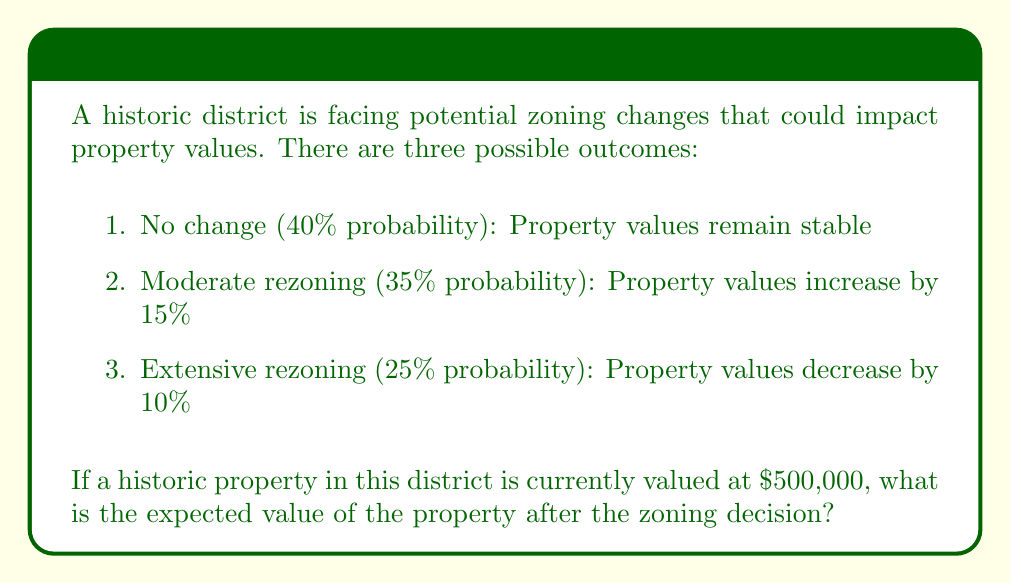Help me with this question. To calculate the expected value, we need to multiply each possible outcome by its probability and sum the results. Let's break it down step-by-step:

1. No change (40% probability):
   $500,000 \times 0.40 = $200,000$

2. Moderate rezoning (35% probability):
   $500,000 \times 1.15 \times 0.35 = $201,250$

3. Extensive rezoning (25% probability):
   $500,000 \times 0.90 \times 0.25 = $112,500$

Now, we sum these probability-weighted outcomes:

$$ \text{Expected Value} = $200,000 + $201,250 + $112,500 = $513,750 $$

Therefore, the expected value of the property after the zoning decision is $513,750.
Answer: $513,750 